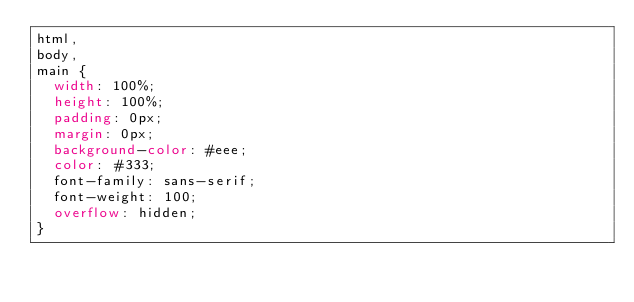Convert code to text. <code><loc_0><loc_0><loc_500><loc_500><_CSS_>html,
body,
main {
  width: 100%;
  height: 100%;
  padding: 0px;
  margin: 0px;
  background-color: #eee;
  color: #333;
  font-family: sans-serif;
  font-weight: 100;
  overflow: hidden;
}
</code> 